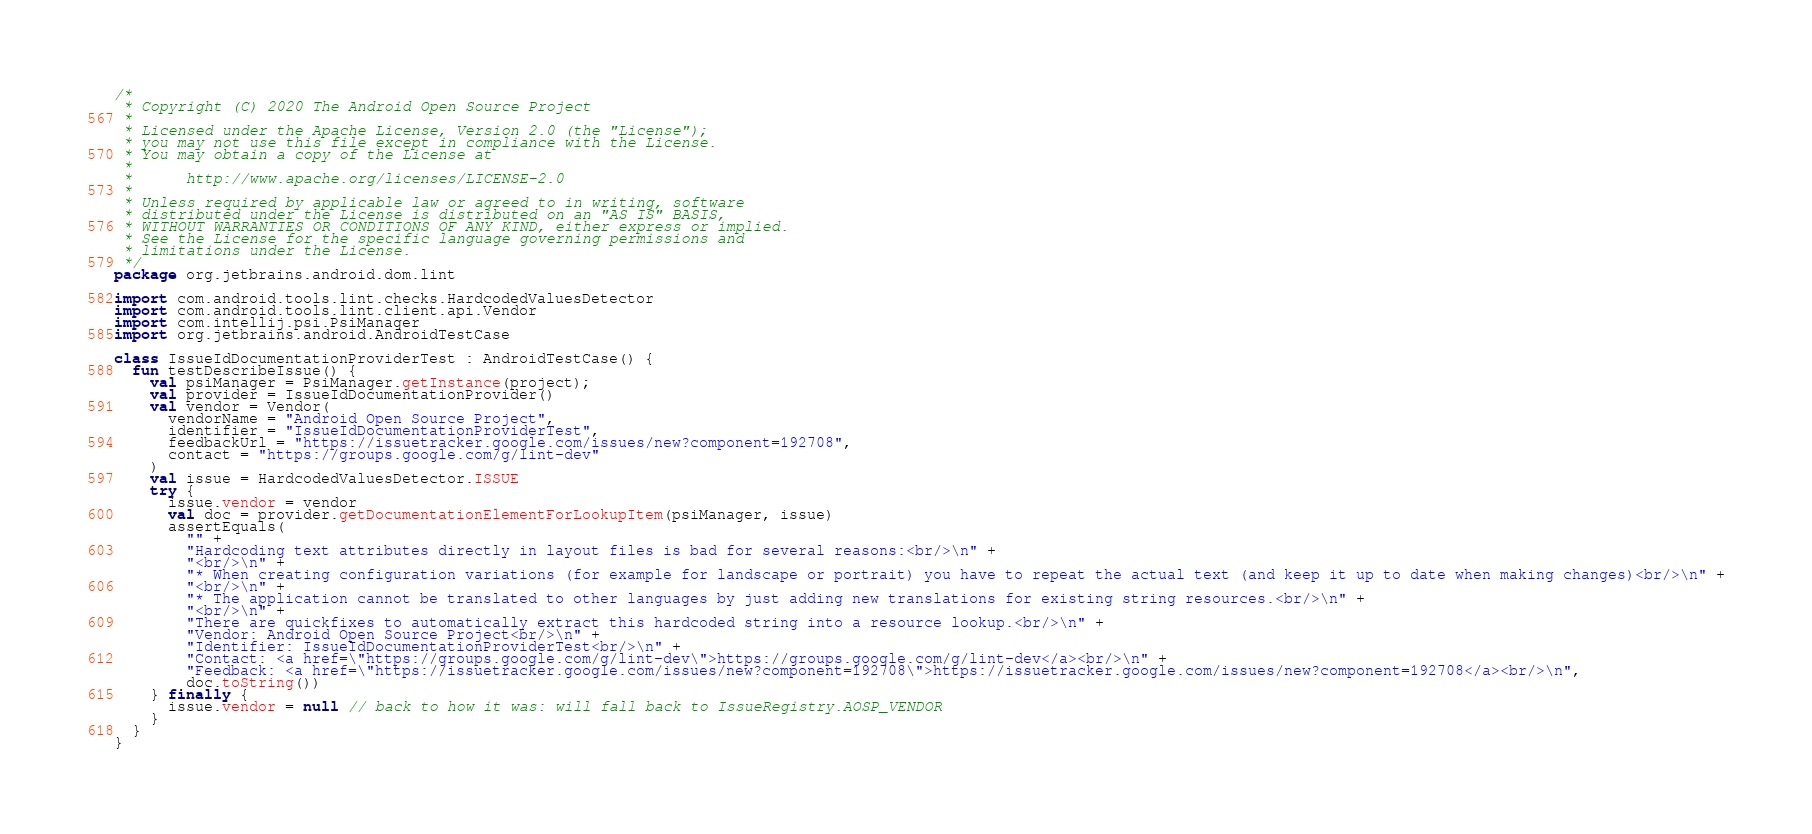<code> <loc_0><loc_0><loc_500><loc_500><_Kotlin_>/*
 * Copyright (C) 2020 The Android Open Source Project
 *
 * Licensed under the Apache License, Version 2.0 (the "License");
 * you may not use this file except in compliance with the License.
 * You may obtain a copy of the License at
 *
 *      http://www.apache.org/licenses/LICENSE-2.0
 *
 * Unless required by applicable law or agreed to in writing, software
 * distributed under the License is distributed on an "AS IS" BASIS,
 * WITHOUT WARRANTIES OR CONDITIONS OF ANY KIND, either express or implied.
 * See the License for the specific language governing permissions and
 * limitations under the License.
 */
package org.jetbrains.android.dom.lint

import com.android.tools.lint.checks.HardcodedValuesDetector
import com.android.tools.lint.client.api.Vendor
import com.intellij.psi.PsiManager
import org.jetbrains.android.AndroidTestCase

class IssueIdDocumentationProviderTest : AndroidTestCase() {
  fun testDescribeIssue() {
    val psiManager = PsiManager.getInstance(project);
    val provider = IssueIdDocumentationProvider()
    val vendor = Vendor(
      vendorName = "Android Open Source Project",
      identifier = "IssueIdDocumentationProviderTest",
      feedbackUrl = "https://issuetracker.google.com/issues/new?component=192708",
      contact = "https://groups.google.com/g/lint-dev"
    )
    val issue = HardcodedValuesDetector.ISSUE
    try {
      issue.vendor = vendor
      val doc = provider.getDocumentationElementForLookupItem(psiManager, issue)
      assertEquals(
        "" +
        "Hardcoding text attributes directly in layout files is bad for several reasons:<br/>\n" +
        "<br/>\n" +
        "* When creating configuration variations (for example for landscape or portrait) you have to repeat the actual text (and keep it up to date when making changes)<br/>\n" +
        "<br/>\n" +
        "* The application cannot be translated to other languages by just adding new translations for existing string resources.<br/>\n" +
        "<br/>\n" +
        "There are quickfixes to automatically extract this hardcoded string into a resource lookup.<br/>\n" +
        "Vendor: Android Open Source Project<br/>\n" +
        "Identifier: IssueIdDocumentationProviderTest<br/>\n" +
        "Contact: <a href=\"https://groups.google.com/g/lint-dev\">https://groups.google.com/g/lint-dev</a><br/>\n" +
        "Feedback: <a href=\"https://issuetracker.google.com/issues/new?component=192708\">https://issuetracker.google.com/issues/new?component=192708</a><br/>\n",
        doc.toString())
    } finally {
      issue.vendor = null // back to how it was: will fall back to IssueRegistry.AOSP_VENDOR
    }
  }
}</code> 